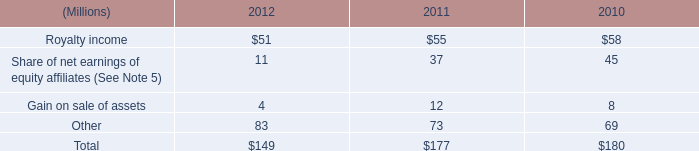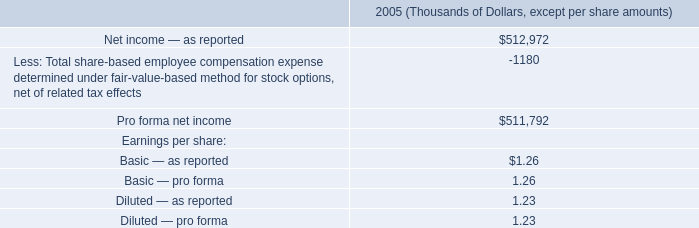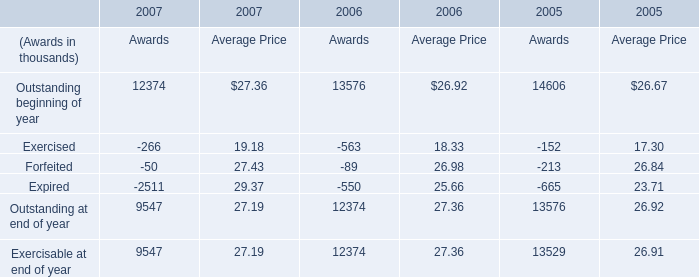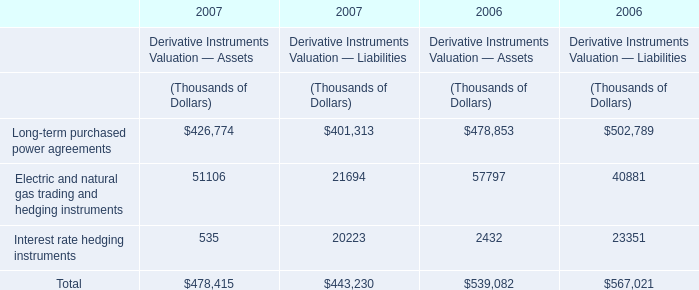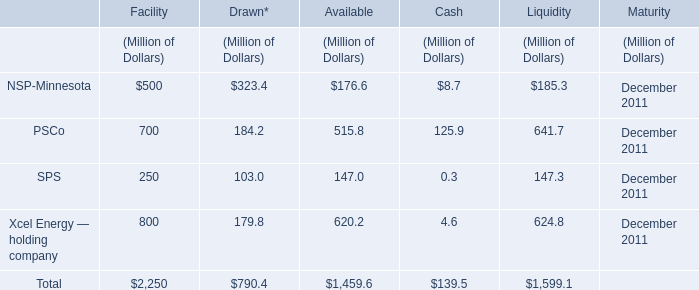What was the total amount of NSP-Minnesota in the range of 1 and500 in 2011 (in million) 
Computations: ((((500 + 323.4) + 176.6) + 8.7) + 185.3)
Answer: 1194.0. 